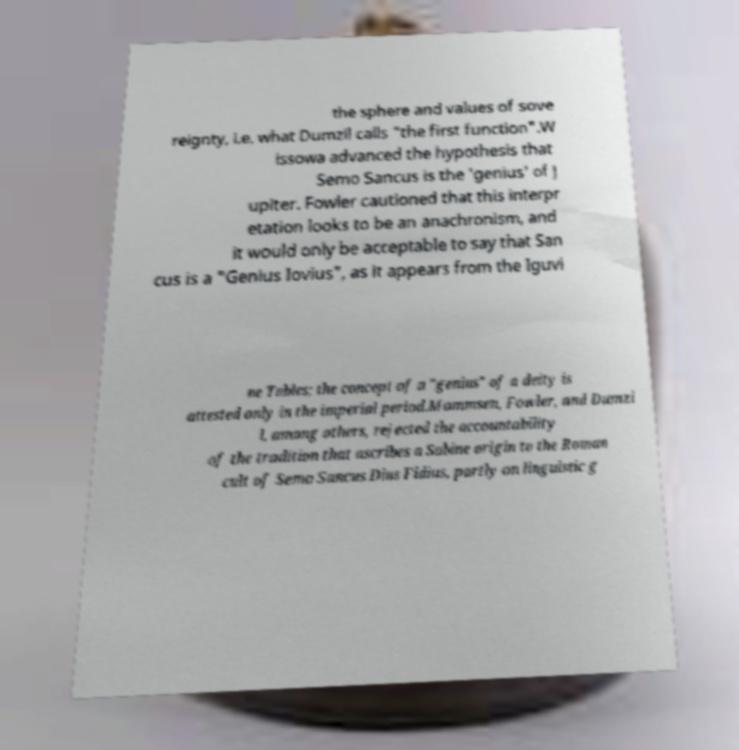Could you extract and type out the text from this image? the sphere and values of sove reignty, i.e. what Dumzil calls "the first function".W issowa advanced the hypothesis that Semo Sancus is the 'genius' of J upiter. Fowler cautioned that this interpr etation looks to be an anachronism, and it would only be acceptable to say that San cus is a "Genius Iovius", as it appears from the Iguvi ne Tables; the concept of a "genius" of a deity is attested only in the imperial period.Mommsen, Fowler, and Dumzi l, among others, rejected the accountability of the tradition that ascribes a Sabine origin to the Roman cult of Semo Sancus Dius Fidius, partly on linguistic g 